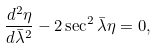<formula> <loc_0><loc_0><loc_500><loc_500>\frac { d ^ { 2 } \eta } { d { \bar { \lambda } } ^ { 2 } } - 2 \sec ^ { 2 } { \bar { \lambda } } \eta = 0 ,</formula> 